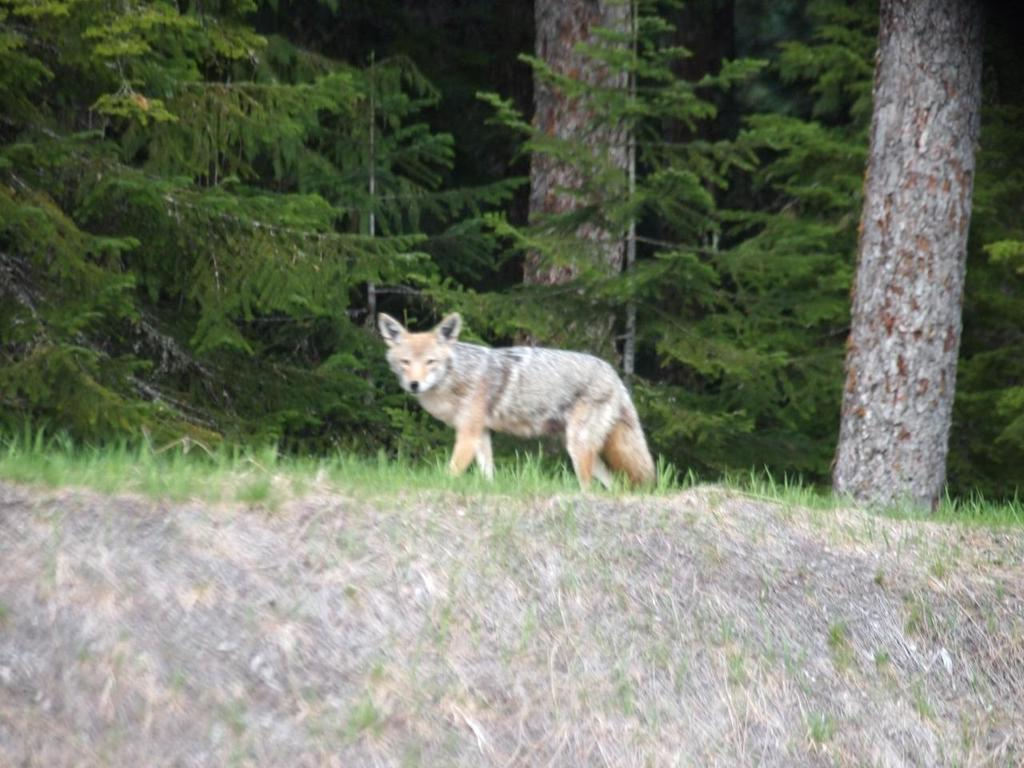What animal is present in the image? There is a wolf in the image. What is the wolf doing in the image? The wolf is walking on the ground in the image. What type of vegetation can be seen at the bottom of the image? There is green grass at the bottom of the image. What can be seen in the background of the image? There are trees in the background of the image. What type of environment might the image be set in? The image appears to be taken in a forest. Can you see the wolf giving a kiss to the trees in the image? No, there is no indication of the wolf giving a kiss to the trees in the image. 